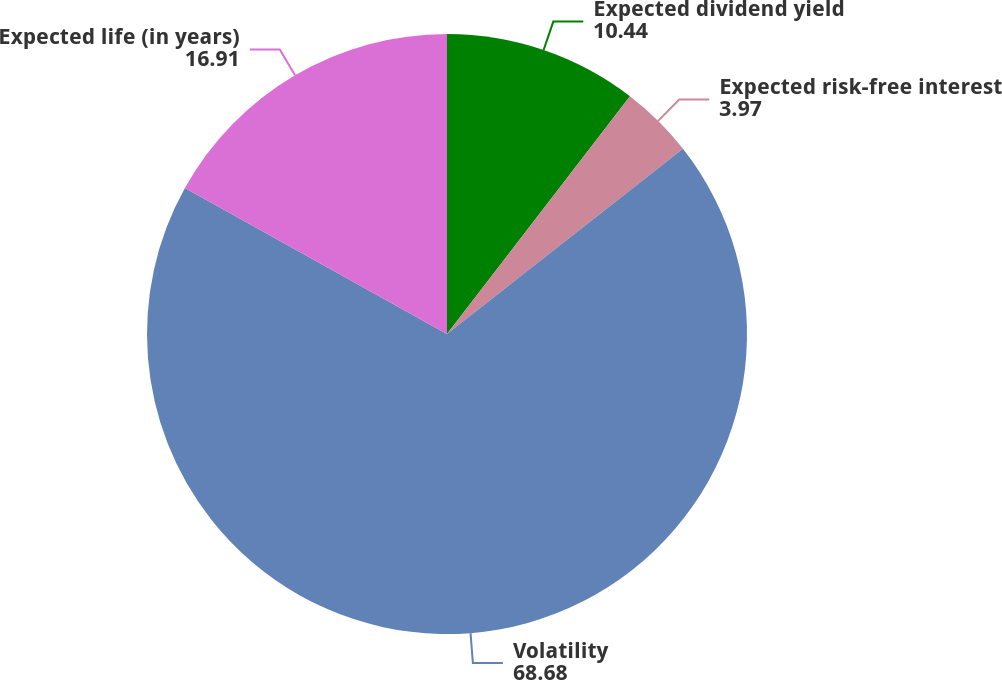<chart> <loc_0><loc_0><loc_500><loc_500><pie_chart><fcel>Expected dividend yield<fcel>Expected risk-free interest<fcel>Volatility<fcel>Expected life (in years)<nl><fcel>10.44%<fcel>3.97%<fcel>68.68%<fcel>16.91%<nl></chart> 